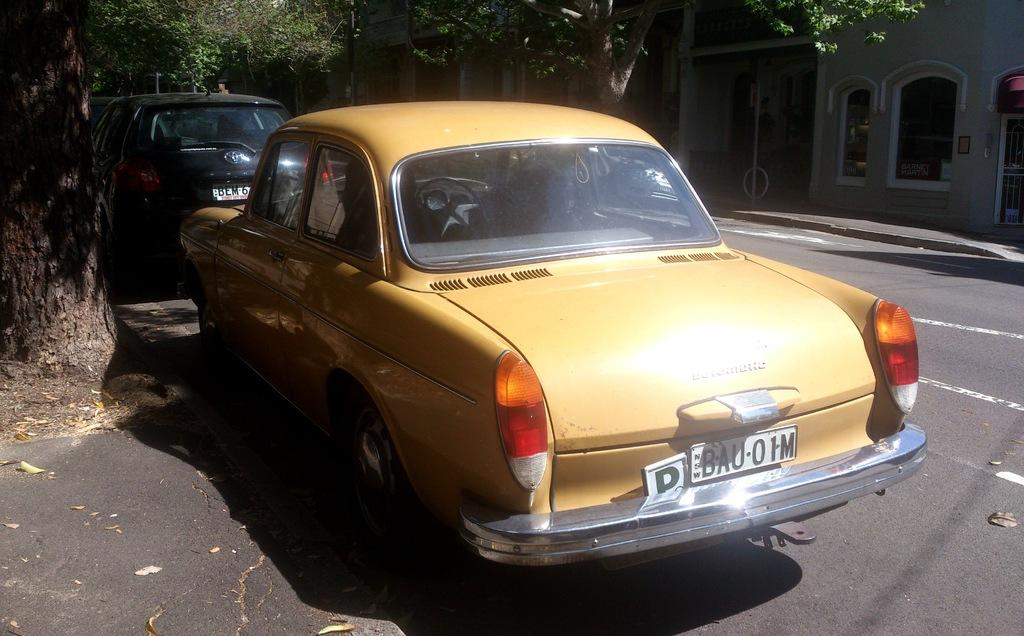What can be seen on the road in the image? There are vehicles on the road in the image. What structures are visible in the image? There are buildings visible in the image. What type of vegetation is present in the image? There are trees in the image. How many geese are sitting on the base in the image? There are no geese or base present in the image. What type of crack is visible on the trees in the image? There are no cracks visible on the trees in the image. 